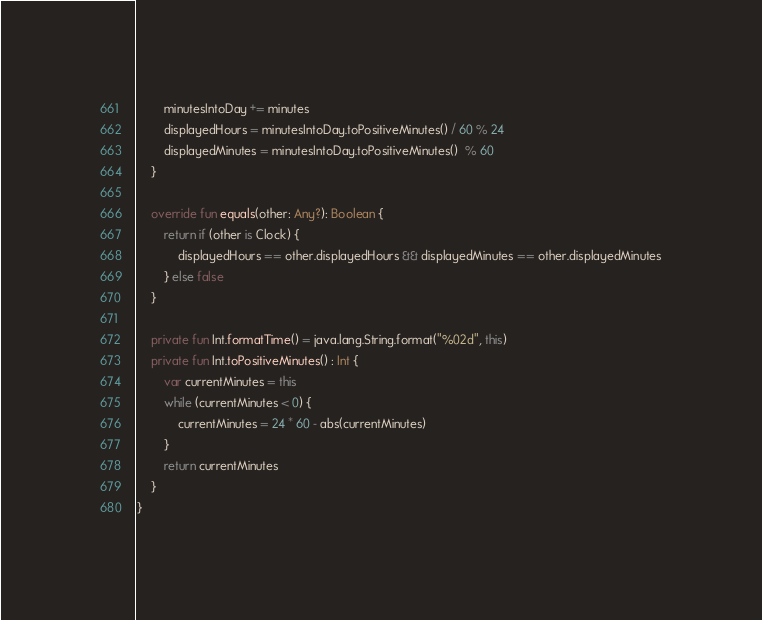<code> <loc_0><loc_0><loc_500><loc_500><_Kotlin_>        minutesIntoDay += minutes
        displayedHours = minutesIntoDay.toPositiveMinutes() / 60 % 24
        displayedMinutes = minutesIntoDay.toPositiveMinutes()  % 60
    }

    override fun equals(other: Any?): Boolean {
        return if (other is Clock) {
            displayedHours == other.displayedHours && displayedMinutes == other.displayedMinutes
        } else false
    }

    private fun Int.formatTime() = java.lang.String.format("%02d", this)
    private fun Int.toPositiveMinutes() : Int {
        var currentMinutes = this
        while (currentMinutes < 0) {
            currentMinutes = 24 * 60 - abs(currentMinutes)
        }
        return currentMinutes
    }
}</code> 